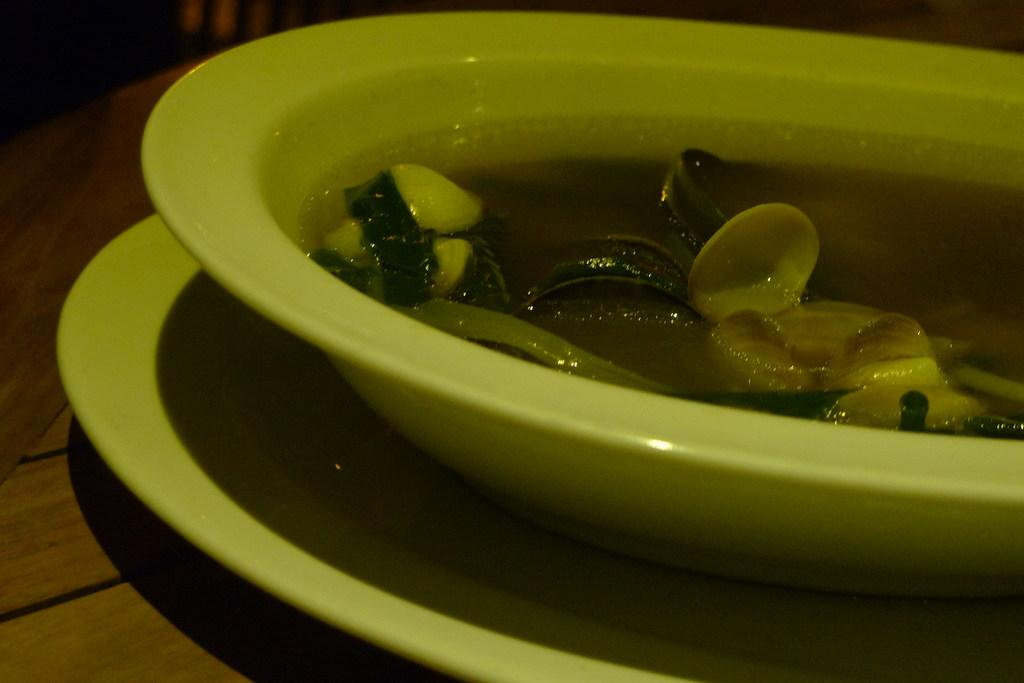What is in the bowl that is visible in the image? There is food in a bowl in the image. How is the bowl positioned in relation to other objects? The bowl is placed on a white plate. What type of surface can be seen on the left side of the image? There is a wooden surface on the left side of the image. What type of coat is being worn by the rain in the image? There is no rain or coat present in the image. How does the cast affect the food in the bowl in the image? There is no cast present in the image, so it cannot affect the food in the bowl. 